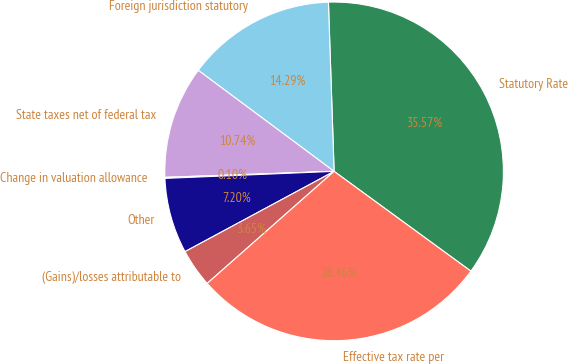Convert chart to OTSL. <chart><loc_0><loc_0><loc_500><loc_500><pie_chart><fcel>Statutory Rate<fcel>Foreign jurisdiction statutory<fcel>State taxes net of federal tax<fcel>Change in valuation allowance<fcel>Other<fcel>(Gains)/losses attributable to<fcel>Effective tax rate per<nl><fcel>35.57%<fcel>14.29%<fcel>10.74%<fcel>0.1%<fcel>7.2%<fcel>3.65%<fcel>28.46%<nl></chart> 